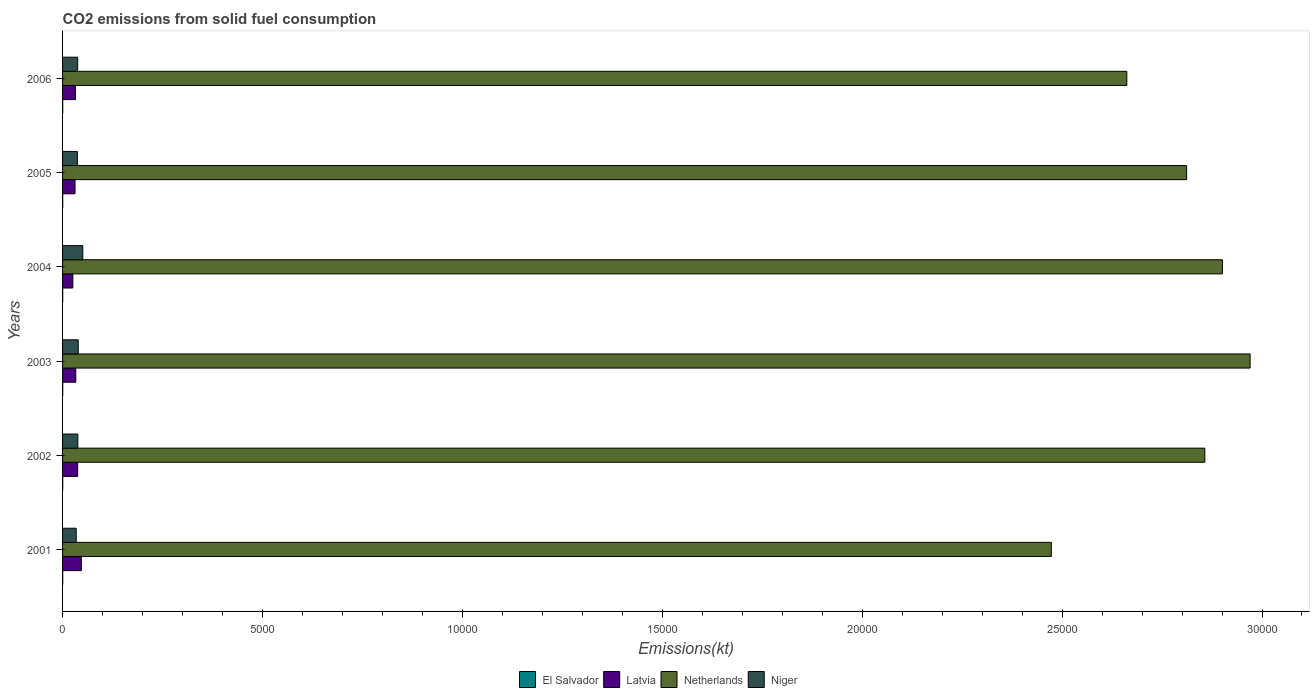What is the label of the 2nd group of bars from the top?
Offer a very short reply. 2005. In how many cases, is the number of bars for a given year not equal to the number of legend labels?
Your answer should be very brief. 0. What is the amount of CO2 emitted in Niger in 2004?
Your response must be concise. 506.05. Across all years, what is the maximum amount of CO2 emitted in Netherlands?
Provide a short and direct response. 2.97e+04. Across all years, what is the minimum amount of CO2 emitted in El Salvador?
Ensure brevity in your answer.  3.67. In which year was the amount of CO2 emitted in Niger maximum?
Offer a terse response. 2004. What is the total amount of CO2 emitted in Netherlands in the graph?
Keep it short and to the point. 1.67e+05. What is the difference between the amount of CO2 emitted in Netherlands in 2001 and that in 2005?
Your answer should be very brief. -3384.64. What is the difference between the amount of CO2 emitted in Latvia in 2006 and the amount of CO2 emitted in El Salvador in 2003?
Ensure brevity in your answer.  319.03. What is the average amount of CO2 emitted in El Salvador per year?
Ensure brevity in your answer.  3.67. In the year 2003, what is the difference between the amount of CO2 emitted in El Salvador and amount of CO2 emitted in Netherlands?
Make the answer very short. -2.97e+04. Is the amount of CO2 emitted in Netherlands in 2002 less than that in 2006?
Offer a terse response. No. What is the difference between the highest and the second highest amount of CO2 emitted in Niger?
Provide a short and direct response. 113.68. What is the difference between the highest and the lowest amount of CO2 emitted in Niger?
Make the answer very short. 165.01. In how many years, is the amount of CO2 emitted in Netherlands greater than the average amount of CO2 emitted in Netherlands taken over all years?
Ensure brevity in your answer.  4. Is the sum of the amount of CO2 emitted in El Salvador in 2001 and 2005 greater than the maximum amount of CO2 emitted in Niger across all years?
Your response must be concise. No. What does the 2nd bar from the top in 2001 represents?
Keep it short and to the point. Netherlands. Is it the case that in every year, the sum of the amount of CO2 emitted in Netherlands and amount of CO2 emitted in El Salvador is greater than the amount of CO2 emitted in Latvia?
Your answer should be compact. Yes. Are the values on the major ticks of X-axis written in scientific E-notation?
Make the answer very short. No. Does the graph contain grids?
Offer a very short reply. No. How are the legend labels stacked?
Offer a terse response. Horizontal. What is the title of the graph?
Make the answer very short. CO2 emissions from solid fuel consumption. What is the label or title of the X-axis?
Your answer should be very brief. Emissions(kt). What is the Emissions(kt) of El Salvador in 2001?
Offer a terse response. 3.67. What is the Emissions(kt) of Latvia in 2001?
Ensure brevity in your answer.  469.38. What is the Emissions(kt) in Netherlands in 2001?
Provide a short and direct response. 2.47e+04. What is the Emissions(kt) in Niger in 2001?
Provide a succinct answer. 341.03. What is the Emissions(kt) in El Salvador in 2002?
Offer a very short reply. 3.67. What is the Emissions(kt) of Latvia in 2002?
Give a very brief answer. 377.7. What is the Emissions(kt) in Netherlands in 2002?
Your answer should be compact. 2.86e+04. What is the Emissions(kt) of Niger in 2002?
Provide a succinct answer. 381.37. What is the Emissions(kt) in El Salvador in 2003?
Offer a very short reply. 3.67. What is the Emissions(kt) of Latvia in 2003?
Offer a very short reply. 330.03. What is the Emissions(kt) of Netherlands in 2003?
Keep it short and to the point. 2.97e+04. What is the Emissions(kt) of Niger in 2003?
Make the answer very short. 392.37. What is the Emissions(kt) in El Salvador in 2004?
Keep it short and to the point. 3.67. What is the Emissions(kt) of Latvia in 2004?
Your response must be concise. 256.69. What is the Emissions(kt) in Netherlands in 2004?
Your answer should be very brief. 2.90e+04. What is the Emissions(kt) of Niger in 2004?
Your response must be concise. 506.05. What is the Emissions(kt) in El Salvador in 2005?
Provide a short and direct response. 3.67. What is the Emissions(kt) of Latvia in 2005?
Ensure brevity in your answer.  311.69. What is the Emissions(kt) in Netherlands in 2005?
Your response must be concise. 2.81e+04. What is the Emissions(kt) of Niger in 2005?
Your answer should be compact. 370.37. What is the Emissions(kt) in El Salvador in 2006?
Your answer should be compact. 3.67. What is the Emissions(kt) of Latvia in 2006?
Keep it short and to the point. 322.7. What is the Emissions(kt) in Netherlands in 2006?
Give a very brief answer. 2.66e+04. What is the Emissions(kt) of Niger in 2006?
Ensure brevity in your answer.  377.7. Across all years, what is the maximum Emissions(kt) in El Salvador?
Make the answer very short. 3.67. Across all years, what is the maximum Emissions(kt) of Latvia?
Your response must be concise. 469.38. Across all years, what is the maximum Emissions(kt) in Netherlands?
Keep it short and to the point. 2.97e+04. Across all years, what is the maximum Emissions(kt) in Niger?
Your answer should be compact. 506.05. Across all years, what is the minimum Emissions(kt) of El Salvador?
Offer a very short reply. 3.67. Across all years, what is the minimum Emissions(kt) in Latvia?
Make the answer very short. 256.69. Across all years, what is the minimum Emissions(kt) in Netherlands?
Offer a terse response. 2.47e+04. Across all years, what is the minimum Emissions(kt) in Niger?
Offer a terse response. 341.03. What is the total Emissions(kt) in El Salvador in the graph?
Provide a short and direct response. 22. What is the total Emissions(kt) in Latvia in the graph?
Your response must be concise. 2068.19. What is the total Emissions(kt) in Netherlands in the graph?
Make the answer very short. 1.67e+05. What is the total Emissions(kt) of Niger in the graph?
Keep it short and to the point. 2368.88. What is the difference between the Emissions(kt) of Latvia in 2001 and that in 2002?
Give a very brief answer. 91.67. What is the difference between the Emissions(kt) in Netherlands in 2001 and that in 2002?
Keep it short and to the point. -3839.35. What is the difference between the Emissions(kt) in Niger in 2001 and that in 2002?
Provide a short and direct response. -40.34. What is the difference between the Emissions(kt) in Latvia in 2001 and that in 2003?
Provide a short and direct response. 139.35. What is the difference between the Emissions(kt) of Netherlands in 2001 and that in 2003?
Ensure brevity in your answer.  -4972.45. What is the difference between the Emissions(kt) in Niger in 2001 and that in 2003?
Offer a terse response. -51.34. What is the difference between the Emissions(kt) in El Salvador in 2001 and that in 2004?
Provide a succinct answer. 0. What is the difference between the Emissions(kt) of Latvia in 2001 and that in 2004?
Give a very brief answer. 212.69. What is the difference between the Emissions(kt) in Netherlands in 2001 and that in 2004?
Provide a short and direct response. -4279.39. What is the difference between the Emissions(kt) of Niger in 2001 and that in 2004?
Offer a very short reply. -165.01. What is the difference between the Emissions(kt) in El Salvador in 2001 and that in 2005?
Your response must be concise. 0. What is the difference between the Emissions(kt) of Latvia in 2001 and that in 2005?
Offer a very short reply. 157.68. What is the difference between the Emissions(kt) in Netherlands in 2001 and that in 2005?
Make the answer very short. -3384.64. What is the difference between the Emissions(kt) of Niger in 2001 and that in 2005?
Provide a succinct answer. -29.34. What is the difference between the Emissions(kt) in El Salvador in 2001 and that in 2006?
Provide a short and direct response. 0. What is the difference between the Emissions(kt) in Latvia in 2001 and that in 2006?
Offer a very short reply. 146.68. What is the difference between the Emissions(kt) in Netherlands in 2001 and that in 2006?
Offer a very short reply. -1888.51. What is the difference between the Emissions(kt) in Niger in 2001 and that in 2006?
Your response must be concise. -36.67. What is the difference between the Emissions(kt) of Latvia in 2002 and that in 2003?
Your response must be concise. 47.67. What is the difference between the Emissions(kt) in Netherlands in 2002 and that in 2003?
Ensure brevity in your answer.  -1133.1. What is the difference between the Emissions(kt) in Niger in 2002 and that in 2003?
Your response must be concise. -11. What is the difference between the Emissions(kt) of El Salvador in 2002 and that in 2004?
Make the answer very short. 0. What is the difference between the Emissions(kt) in Latvia in 2002 and that in 2004?
Offer a terse response. 121.01. What is the difference between the Emissions(kt) of Netherlands in 2002 and that in 2004?
Provide a short and direct response. -440.04. What is the difference between the Emissions(kt) in Niger in 2002 and that in 2004?
Your response must be concise. -124.68. What is the difference between the Emissions(kt) of El Salvador in 2002 and that in 2005?
Ensure brevity in your answer.  0. What is the difference between the Emissions(kt) of Latvia in 2002 and that in 2005?
Keep it short and to the point. 66.01. What is the difference between the Emissions(kt) in Netherlands in 2002 and that in 2005?
Offer a terse response. 454.71. What is the difference between the Emissions(kt) in Niger in 2002 and that in 2005?
Give a very brief answer. 11. What is the difference between the Emissions(kt) of El Salvador in 2002 and that in 2006?
Provide a succinct answer. 0. What is the difference between the Emissions(kt) in Latvia in 2002 and that in 2006?
Provide a short and direct response. 55.01. What is the difference between the Emissions(kt) in Netherlands in 2002 and that in 2006?
Provide a short and direct response. 1950.84. What is the difference between the Emissions(kt) in Niger in 2002 and that in 2006?
Give a very brief answer. 3.67. What is the difference between the Emissions(kt) of El Salvador in 2003 and that in 2004?
Ensure brevity in your answer.  0. What is the difference between the Emissions(kt) of Latvia in 2003 and that in 2004?
Ensure brevity in your answer.  73.34. What is the difference between the Emissions(kt) of Netherlands in 2003 and that in 2004?
Make the answer very short. 693.06. What is the difference between the Emissions(kt) of Niger in 2003 and that in 2004?
Offer a very short reply. -113.68. What is the difference between the Emissions(kt) in Latvia in 2003 and that in 2005?
Offer a terse response. 18.34. What is the difference between the Emissions(kt) of Netherlands in 2003 and that in 2005?
Ensure brevity in your answer.  1587.81. What is the difference between the Emissions(kt) in Niger in 2003 and that in 2005?
Offer a terse response. 22. What is the difference between the Emissions(kt) of El Salvador in 2003 and that in 2006?
Your answer should be very brief. 0. What is the difference between the Emissions(kt) in Latvia in 2003 and that in 2006?
Offer a very short reply. 7.33. What is the difference between the Emissions(kt) in Netherlands in 2003 and that in 2006?
Provide a succinct answer. 3083.95. What is the difference between the Emissions(kt) of Niger in 2003 and that in 2006?
Offer a terse response. 14.67. What is the difference between the Emissions(kt) in Latvia in 2004 and that in 2005?
Make the answer very short. -55.01. What is the difference between the Emissions(kt) of Netherlands in 2004 and that in 2005?
Offer a terse response. 894.75. What is the difference between the Emissions(kt) of Niger in 2004 and that in 2005?
Your response must be concise. 135.68. What is the difference between the Emissions(kt) of El Salvador in 2004 and that in 2006?
Your answer should be compact. 0. What is the difference between the Emissions(kt) in Latvia in 2004 and that in 2006?
Your response must be concise. -66.01. What is the difference between the Emissions(kt) of Netherlands in 2004 and that in 2006?
Your answer should be very brief. 2390.88. What is the difference between the Emissions(kt) of Niger in 2004 and that in 2006?
Offer a very short reply. 128.34. What is the difference between the Emissions(kt) of El Salvador in 2005 and that in 2006?
Ensure brevity in your answer.  0. What is the difference between the Emissions(kt) of Latvia in 2005 and that in 2006?
Make the answer very short. -11. What is the difference between the Emissions(kt) in Netherlands in 2005 and that in 2006?
Give a very brief answer. 1496.14. What is the difference between the Emissions(kt) of Niger in 2005 and that in 2006?
Offer a terse response. -7.33. What is the difference between the Emissions(kt) of El Salvador in 2001 and the Emissions(kt) of Latvia in 2002?
Make the answer very short. -374.03. What is the difference between the Emissions(kt) of El Salvador in 2001 and the Emissions(kt) of Netherlands in 2002?
Offer a terse response. -2.86e+04. What is the difference between the Emissions(kt) of El Salvador in 2001 and the Emissions(kt) of Niger in 2002?
Give a very brief answer. -377.7. What is the difference between the Emissions(kt) of Latvia in 2001 and the Emissions(kt) of Netherlands in 2002?
Offer a very short reply. -2.81e+04. What is the difference between the Emissions(kt) in Latvia in 2001 and the Emissions(kt) in Niger in 2002?
Your response must be concise. 88.01. What is the difference between the Emissions(kt) in Netherlands in 2001 and the Emissions(kt) in Niger in 2002?
Make the answer very short. 2.43e+04. What is the difference between the Emissions(kt) of El Salvador in 2001 and the Emissions(kt) of Latvia in 2003?
Give a very brief answer. -326.36. What is the difference between the Emissions(kt) of El Salvador in 2001 and the Emissions(kt) of Netherlands in 2003?
Make the answer very short. -2.97e+04. What is the difference between the Emissions(kt) in El Salvador in 2001 and the Emissions(kt) in Niger in 2003?
Provide a short and direct response. -388.7. What is the difference between the Emissions(kt) in Latvia in 2001 and the Emissions(kt) in Netherlands in 2003?
Provide a succinct answer. -2.92e+04. What is the difference between the Emissions(kt) of Latvia in 2001 and the Emissions(kt) of Niger in 2003?
Provide a short and direct response. 77.01. What is the difference between the Emissions(kt) of Netherlands in 2001 and the Emissions(kt) of Niger in 2003?
Your answer should be very brief. 2.43e+04. What is the difference between the Emissions(kt) in El Salvador in 2001 and the Emissions(kt) in Latvia in 2004?
Provide a succinct answer. -253.02. What is the difference between the Emissions(kt) in El Salvador in 2001 and the Emissions(kt) in Netherlands in 2004?
Provide a short and direct response. -2.90e+04. What is the difference between the Emissions(kt) in El Salvador in 2001 and the Emissions(kt) in Niger in 2004?
Offer a terse response. -502.38. What is the difference between the Emissions(kt) in Latvia in 2001 and the Emissions(kt) in Netherlands in 2004?
Keep it short and to the point. -2.85e+04. What is the difference between the Emissions(kt) of Latvia in 2001 and the Emissions(kt) of Niger in 2004?
Your answer should be very brief. -36.67. What is the difference between the Emissions(kt) of Netherlands in 2001 and the Emissions(kt) of Niger in 2004?
Your response must be concise. 2.42e+04. What is the difference between the Emissions(kt) in El Salvador in 2001 and the Emissions(kt) in Latvia in 2005?
Offer a very short reply. -308.03. What is the difference between the Emissions(kt) in El Salvador in 2001 and the Emissions(kt) in Netherlands in 2005?
Offer a terse response. -2.81e+04. What is the difference between the Emissions(kt) in El Salvador in 2001 and the Emissions(kt) in Niger in 2005?
Provide a short and direct response. -366.7. What is the difference between the Emissions(kt) of Latvia in 2001 and the Emissions(kt) of Netherlands in 2005?
Offer a terse response. -2.76e+04. What is the difference between the Emissions(kt) of Latvia in 2001 and the Emissions(kt) of Niger in 2005?
Offer a very short reply. 99.01. What is the difference between the Emissions(kt) in Netherlands in 2001 and the Emissions(kt) in Niger in 2005?
Provide a succinct answer. 2.44e+04. What is the difference between the Emissions(kt) of El Salvador in 2001 and the Emissions(kt) of Latvia in 2006?
Ensure brevity in your answer.  -319.03. What is the difference between the Emissions(kt) of El Salvador in 2001 and the Emissions(kt) of Netherlands in 2006?
Make the answer very short. -2.66e+04. What is the difference between the Emissions(kt) of El Salvador in 2001 and the Emissions(kt) of Niger in 2006?
Provide a short and direct response. -374.03. What is the difference between the Emissions(kt) of Latvia in 2001 and the Emissions(kt) of Netherlands in 2006?
Give a very brief answer. -2.61e+04. What is the difference between the Emissions(kt) in Latvia in 2001 and the Emissions(kt) in Niger in 2006?
Make the answer very short. 91.67. What is the difference between the Emissions(kt) of Netherlands in 2001 and the Emissions(kt) of Niger in 2006?
Your answer should be very brief. 2.44e+04. What is the difference between the Emissions(kt) in El Salvador in 2002 and the Emissions(kt) in Latvia in 2003?
Offer a terse response. -326.36. What is the difference between the Emissions(kt) of El Salvador in 2002 and the Emissions(kt) of Netherlands in 2003?
Offer a very short reply. -2.97e+04. What is the difference between the Emissions(kt) of El Salvador in 2002 and the Emissions(kt) of Niger in 2003?
Provide a succinct answer. -388.7. What is the difference between the Emissions(kt) of Latvia in 2002 and the Emissions(kt) of Netherlands in 2003?
Provide a short and direct response. -2.93e+04. What is the difference between the Emissions(kt) of Latvia in 2002 and the Emissions(kt) of Niger in 2003?
Provide a short and direct response. -14.67. What is the difference between the Emissions(kt) of Netherlands in 2002 and the Emissions(kt) of Niger in 2003?
Offer a terse response. 2.82e+04. What is the difference between the Emissions(kt) of El Salvador in 2002 and the Emissions(kt) of Latvia in 2004?
Make the answer very short. -253.02. What is the difference between the Emissions(kt) of El Salvador in 2002 and the Emissions(kt) of Netherlands in 2004?
Your response must be concise. -2.90e+04. What is the difference between the Emissions(kt) of El Salvador in 2002 and the Emissions(kt) of Niger in 2004?
Keep it short and to the point. -502.38. What is the difference between the Emissions(kt) of Latvia in 2002 and the Emissions(kt) of Netherlands in 2004?
Keep it short and to the point. -2.86e+04. What is the difference between the Emissions(kt) in Latvia in 2002 and the Emissions(kt) in Niger in 2004?
Your answer should be very brief. -128.34. What is the difference between the Emissions(kt) in Netherlands in 2002 and the Emissions(kt) in Niger in 2004?
Provide a short and direct response. 2.81e+04. What is the difference between the Emissions(kt) in El Salvador in 2002 and the Emissions(kt) in Latvia in 2005?
Provide a short and direct response. -308.03. What is the difference between the Emissions(kt) of El Salvador in 2002 and the Emissions(kt) of Netherlands in 2005?
Provide a succinct answer. -2.81e+04. What is the difference between the Emissions(kt) of El Salvador in 2002 and the Emissions(kt) of Niger in 2005?
Provide a succinct answer. -366.7. What is the difference between the Emissions(kt) of Latvia in 2002 and the Emissions(kt) of Netherlands in 2005?
Your answer should be very brief. -2.77e+04. What is the difference between the Emissions(kt) of Latvia in 2002 and the Emissions(kt) of Niger in 2005?
Provide a succinct answer. 7.33. What is the difference between the Emissions(kt) of Netherlands in 2002 and the Emissions(kt) of Niger in 2005?
Give a very brief answer. 2.82e+04. What is the difference between the Emissions(kt) of El Salvador in 2002 and the Emissions(kt) of Latvia in 2006?
Provide a succinct answer. -319.03. What is the difference between the Emissions(kt) of El Salvador in 2002 and the Emissions(kt) of Netherlands in 2006?
Provide a short and direct response. -2.66e+04. What is the difference between the Emissions(kt) of El Salvador in 2002 and the Emissions(kt) of Niger in 2006?
Offer a terse response. -374.03. What is the difference between the Emissions(kt) in Latvia in 2002 and the Emissions(kt) in Netherlands in 2006?
Give a very brief answer. -2.62e+04. What is the difference between the Emissions(kt) of Latvia in 2002 and the Emissions(kt) of Niger in 2006?
Give a very brief answer. 0. What is the difference between the Emissions(kt) of Netherlands in 2002 and the Emissions(kt) of Niger in 2006?
Make the answer very short. 2.82e+04. What is the difference between the Emissions(kt) in El Salvador in 2003 and the Emissions(kt) in Latvia in 2004?
Offer a terse response. -253.02. What is the difference between the Emissions(kt) in El Salvador in 2003 and the Emissions(kt) in Netherlands in 2004?
Provide a short and direct response. -2.90e+04. What is the difference between the Emissions(kt) of El Salvador in 2003 and the Emissions(kt) of Niger in 2004?
Provide a succinct answer. -502.38. What is the difference between the Emissions(kt) of Latvia in 2003 and the Emissions(kt) of Netherlands in 2004?
Provide a short and direct response. -2.87e+04. What is the difference between the Emissions(kt) in Latvia in 2003 and the Emissions(kt) in Niger in 2004?
Provide a succinct answer. -176.02. What is the difference between the Emissions(kt) in Netherlands in 2003 and the Emissions(kt) in Niger in 2004?
Your response must be concise. 2.92e+04. What is the difference between the Emissions(kt) in El Salvador in 2003 and the Emissions(kt) in Latvia in 2005?
Your answer should be compact. -308.03. What is the difference between the Emissions(kt) in El Salvador in 2003 and the Emissions(kt) in Netherlands in 2005?
Your response must be concise. -2.81e+04. What is the difference between the Emissions(kt) in El Salvador in 2003 and the Emissions(kt) in Niger in 2005?
Make the answer very short. -366.7. What is the difference between the Emissions(kt) in Latvia in 2003 and the Emissions(kt) in Netherlands in 2005?
Offer a very short reply. -2.78e+04. What is the difference between the Emissions(kt) of Latvia in 2003 and the Emissions(kt) of Niger in 2005?
Offer a terse response. -40.34. What is the difference between the Emissions(kt) of Netherlands in 2003 and the Emissions(kt) of Niger in 2005?
Your response must be concise. 2.93e+04. What is the difference between the Emissions(kt) of El Salvador in 2003 and the Emissions(kt) of Latvia in 2006?
Your response must be concise. -319.03. What is the difference between the Emissions(kt) in El Salvador in 2003 and the Emissions(kt) in Netherlands in 2006?
Provide a succinct answer. -2.66e+04. What is the difference between the Emissions(kt) of El Salvador in 2003 and the Emissions(kt) of Niger in 2006?
Offer a very short reply. -374.03. What is the difference between the Emissions(kt) in Latvia in 2003 and the Emissions(kt) in Netherlands in 2006?
Keep it short and to the point. -2.63e+04. What is the difference between the Emissions(kt) in Latvia in 2003 and the Emissions(kt) in Niger in 2006?
Your answer should be compact. -47.67. What is the difference between the Emissions(kt) in Netherlands in 2003 and the Emissions(kt) in Niger in 2006?
Your answer should be very brief. 2.93e+04. What is the difference between the Emissions(kt) in El Salvador in 2004 and the Emissions(kt) in Latvia in 2005?
Offer a very short reply. -308.03. What is the difference between the Emissions(kt) in El Salvador in 2004 and the Emissions(kt) in Netherlands in 2005?
Your answer should be very brief. -2.81e+04. What is the difference between the Emissions(kt) in El Salvador in 2004 and the Emissions(kt) in Niger in 2005?
Ensure brevity in your answer.  -366.7. What is the difference between the Emissions(kt) of Latvia in 2004 and the Emissions(kt) of Netherlands in 2005?
Your answer should be compact. -2.79e+04. What is the difference between the Emissions(kt) of Latvia in 2004 and the Emissions(kt) of Niger in 2005?
Give a very brief answer. -113.68. What is the difference between the Emissions(kt) of Netherlands in 2004 and the Emissions(kt) of Niger in 2005?
Ensure brevity in your answer.  2.86e+04. What is the difference between the Emissions(kt) in El Salvador in 2004 and the Emissions(kt) in Latvia in 2006?
Offer a very short reply. -319.03. What is the difference between the Emissions(kt) in El Salvador in 2004 and the Emissions(kt) in Netherlands in 2006?
Offer a terse response. -2.66e+04. What is the difference between the Emissions(kt) in El Salvador in 2004 and the Emissions(kt) in Niger in 2006?
Make the answer very short. -374.03. What is the difference between the Emissions(kt) in Latvia in 2004 and the Emissions(kt) in Netherlands in 2006?
Your response must be concise. -2.64e+04. What is the difference between the Emissions(kt) of Latvia in 2004 and the Emissions(kt) of Niger in 2006?
Keep it short and to the point. -121.01. What is the difference between the Emissions(kt) in Netherlands in 2004 and the Emissions(kt) in Niger in 2006?
Provide a succinct answer. 2.86e+04. What is the difference between the Emissions(kt) of El Salvador in 2005 and the Emissions(kt) of Latvia in 2006?
Ensure brevity in your answer.  -319.03. What is the difference between the Emissions(kt) in El Salvador in 2005 and the Emissions(kt) in Netherlands in 2006?
Offer a terse response. -2.66e+04. What is the difference between the Emissions(kt) in El Salvador in 2005 and the Emissions(kt) in Niger in 2006?
Offer a very short reply. -374.03. What is the difference between the Emissions(kt) in Latvia in 2005 and the Emissions(kt) in Netherlands in 2006?
Your answer should be compact. -2.63e+04. What is the difference between the Emissions(kt) in Latvia in 2005 and the Emissions(kt) in Niger in 2006?
Ensure brevity in your answer.  -66.01. What is the difference between the Emissions(kt) in Netherlands in 2005 and the Emissions(kt) in Niger in 2006?
Provide a succinct answer. 2.77e+04. What is the average Emissions(kt) in El Salvador per year?
Your response must be concise. 3.67. What is the average Emissions(kt) of Latvia per year?
Provide a short and direct response. 344.7. What is the average Emissions(kt) in Netherlands per year?
Make the answer very short. 2.78e+04. What is the average Emissions(kt) of Niger per year?
Offer a terse response. 394.81. In the year 2001, what is the difference between the Emissions(kt) of El Salvador and Emissions(kt) of Latvia?
Provide a succinct answer. -465.71. In the year 2001, what is the difference between the Emissions(kt) in El Salvador and Emissions(kt) in Netherlands?
Your answer should be compact. -2.47e+04. In the year 2001, what is the difference between the Emissions(kt) of El Salvador and Emissions(kt) of Niger?
Ensure brevity in your answer.  -337.36. In the year 2001, what is the difference between the Emissions(kt) of Latvia and Emissions(kt) of Netherlands?
Make the answer very short. -2.43e+04. In the year 2001, what is the difference between the Emissions(kt) in Latvia and Emissions(kt) in Niger?
Keep it short and to the point. 128.34. In the year 2001, what is the difference between the Emissions(kt) of Netherlands and Emissions(kt) of Niger?
Your response must be concise. 2.44e+04. In the year 2002, what is the difference between the Emissions(kt) of El Salvador and Emissions(kt) of Latvia?
Give a very brief answer. -374.03. In the year 2002, what is the difference between the Emissions(kt) of El Salvador and Emissions(kt) of Netherlands?
Keep it short and to the point. -2.86e+04. In the year 2002, what is the difference between the Emissions(kt) in El Salvador and Emissions(kt) in Niger?
Your answer should be very brief. -377.7. In the year 2002, what is the difference between the Emissions(kt) of Latvia and Emissions(kt) of Netherlands?
Provide a succinct answer. -2.82e+04. In the year 2002, what is the difference between the Emissions(kt) in Latvia and Emissions(kt) in Niger?
Offer a terse response. -3.67. In the year 2002, what is the difference between the Emissions(kt) of Netherlands and Emissions(kt) of Niger?
Offer a very short reply. 2.82e+04. In the year 2003, what is the difference between the Emissions(kt) in El Salvador and Emissions(kt) in Latvia?
Your answer should be very brief. -326.36. In the year 2003, what is the difference between the Emissions(kt) in El Salvador and Emissions(kt) in Netherlands?
Keep it short and to the point. -2.97e+04. In the year 2003, what is the difference between the Emissions(kt) of El Salvador and Emissions(kt) of Niger?
Make the answer very short. -388.7. In the year 2003, what is the difference between the Emissions(kt) in Latvia and Emissions(kt) in Netherlands?
Provide a short and direct response. -2.94e+04. In the year 2003, what is the difference between the Emissions(kt) of Latvia and Emissions(kt) of Niger?
Your response must be concise. -62.34. In the year 2003, what is the difference between the Emissions(kt) of Netherlands and Emissions(kt) of Niger?
Your response must be concise. 2.93e+04. In the year 2004, what is the difference between the Emissions(kt) of El Salvador and Emissions(kt) of Latvia?
Ensure brevity in your answer.  -253.02. In the year 2004, what is the difference between the Emissions(kt) of El Salvador and Emissions(kt) of Netherlands?
Your answer should be compact. -2.90e+04. In the year 2004, what is the difference between the Emissions(kt) in El Salvador and Emissions(kt) in Niger?
Your response must be concise. -502.38. In the year 2004, what is the difference between the Emissions(kt) of Latvia and Emissions(kt) of Netherlands?
Provide a succinct answer. -2.88e+04. In the year 2004, what is the difference between the Emissions(kt) in Latvia and Emissions(kt) in Niger?
Your response must be concise. -249.36. In the year 2004, what is the difference between the Emissions(kt) of Netherlands and Emissions(kt) of Niger?
Your answer should be very brief. 2.85e+04. In the year 2005, what is the difference between the Emissions(kt) of El Salvador and Emissions(kt) of Latvia?
Keep it short and to the point. -308.03. In the year 2005, what is the difference between the Emissions(kt) in El Salvador and Emissions(kt) in Netherlands?
Offer a very short reply. -2.81e+04. In the year 2005, what is the difference between the Emissions(kt) in El Salvador and Emissions(kt) in Niger?
Make the answer very short. -366.7. In the year 2005, what is the difference between the Emissions(kt) of Latvia and Emissions(kt) of Netherlands?
Provide a short and direct response. -2.78e+04. In the year 2005, what is the difference between the Emissions(kt) in Latvia and Emissions(kt) in Niger?
Provide a succinct answer. -58.67. In the year 2005, what is the difference between the Emissions(kt) in Netherlands and Emissions(kt) in Niger?
Make the answer very short. 2.77e+04. In the year 2006, what is the difference between the Emissions(kt) of El Salvador and Emissions(kt) of Latvia?
Make the answer very short. -319.03. In the year 2006, what is the difference between the Emissions(kt) in El Salvador and Emissions(kt) in Netherlands?
Your response must be concise. -2.66e+04. In the year 2006, what is the difference between the Emissions(kt) in El Salvador and Emissions(kt) in Niger?
Give a very brief answer. -374.03. In the year 2006, what is the difference between the Emissions(kt) in Latvia and Emissions(kt) in Netherlands?
Provide a short and direct response. -2.63e+04. In the year 2006, what is the difference between the Emissions(kt) of Latvia and Emissions(kt) of Niger?
Offer a terse response. -55.01. In the year 2006, what is the difference between the Emissions(kt) in Netherlands and Emissions(kt) in Niger?
Offer a very short reply. 2.62e+04. What is the ratio of the Emissions(kt) in El Salvador in 2001 to that in 2002?
Provide a short and direct response. 1. What is the ratio of the Emissions(kt) in Latvia in 2001 to that in 2002?
Make the answer very short. 1.24. What is the ratio of the Emissions(kt) in Netherlands in 2001 to that in 2002?
Provide a succinct answer. 0.87. What is the ratio of the Emissions(kt) of Niger in 2001 to that in 2002?
Provide a short and direct response. 0.89. What is the ratio of the Emissions(kt) of El Salvador in 2001 to that in 2003?
Ensure brevity in your answer.  1. What is the ratio of the Emissions(kt) in Latvia in 2001 to that in 2003?
Your answer should be very brief. 1.42. What is the ratio of the Emissions(kt) of Netherlands in 2001 to that in 2003?
Provide a short and direct response. 0.83. What is the ratio of the Emissions(kt) in Niger in 2001 to that in 2003?
Offer a very short reply. 0.87. What is the ratio of the Emissions(kt) in Latvia in 2001 to that in 2004?
Ensure brevity in your answer.  1.83. What is the ratio of the Emissions(kt) of Netherlands in 2001 to that in 2004?
Provide a succinct answer. 0.85. What is the ratio of the Emissions(kt) of Niger in 2001 to that in 2004?
Provide a short and direct response. 0.67. What is the ratio of the Emissions(kt) in Latvia in 2001 to that in 2005?
Give a very brief answer. 1.51. What is the ratio of the Emissions(kt) of Netherlands in 2001 to that in 2005?
Your answer should be compact. 0.88. What is the ratio of the Emissions(kt) of Niger in 2001 to that in 2005?
Offer a very short reply. 0.92. What is the ratio of the Emissions(kt) of El Salvador in 2001 to that in 2006?
Offer a very short reply. 1. What is the ratio of the Emissions(kt) of Latvia in 2001 to that in 2006?
Provide a succinct answer. 1.45. What is the ratio of the Emissions(kt) in Netherlands in 2001 to that in 2006?
Provide a succinct answer. 0.93. What is the ratio of the Emissions(kt) in Niger in 2001 to that in 2006?
Your response must be concise. 0.9. What is the ratio of the Emissions(kt) in Latvia in 2002 to that in 2003?
Your response must be concise. 1.14. What is the ratio of the Emissions(kt) in Netherlands in 2002 to that in 2003?
Your answer should be compact. 0.96. What is the ratio of the Emissions(kt) of Niger in 2002 to that in 2003?
Offer a terse response. 0.97. What is the ratio of the Emissions(kt) in El Salvador in 2002 to that in 2004?
Keep it short and to the point. 1. What is the ratio of the Emissions(kt) of Latvia in 2002 to that in 2004?
Keep it short and to the point. 1.47. What is the ratio of the Emissions(kt) in Niger in 2002 to that in 2004?
Offer a terse response. 0.75. What is the ratio of the Emissions(kt) in El Salvador in 2002 to that in 2005?
Your response must be concise. 1. What is the ratio of the Emissions(kt) of Latvia in 2002 to that in 2005?
Give a very brief answer. 1.21. What is the ratio of the Emissions(kt) in Netherlands in 2002 to that in 2005?
Provide a succinct answer. 1.02. What is the ratio of the Emissions(kt) in Niger in 2002 to that in 2005?
Your answer should be very brief. 1.03. What is the ratio of the Emissions(kt) in Latvia in 2002 to that in 2006?
Make the answer very short. 1.17. What is the ratio of the Emissions(kt) of Netherlands in 2002 to that in 2006?
Your answer should be very brief. 1.07. What is the ratio of the Emissions(kt) in Niger in 2002 to that in 2006?
Give a very brief answer. 1.01. What is the ratio of the Emissions(kt) of Netherlands in 2003 to that in 2004?
Ensure brevity in your answer.  1.02. What is the ratio of the Emissions(kt) in Niger in 2003 to that in 2004?
Provide a short and direct response. 0.78. What is the ratio of the Emissions(kt) in Latvia in 2003 to that in 2005?
Your answer should be very brief. 1.06. What is the ratio of the Emissions(kt) in Netherlands in 2003 to that in 2005?
Give a very brief answer. 1.06. What is the ratio of the Emissions(kt) in Niger in 2003 to that in 2005?
Keep it short and to the point. 1.06. What is the ratio of the Emissions(kt) in Latvia in 2003 to that in 2006?
Make the answer very short. 1.02. What is the ratio of the Emissions(kt) of Netherlands in 2003 to that in 2006?
Provide a short and direct response. 1.12. What is the ratio of the Emissions(kt) in Niger in 2003 to that in 2006?
Your answer should be very brief. 1.04. What is the ratio of the Emissions(kt) in El Salvador in 2004 to that in 2005?
Provide a succinct answer. 1. What is the ratio of the Emissions(kt) of Latvia in 2004 to that in 2005?
Give a very brief answer. 0.82. What is the ratio of the Emissions(kt) in Netherlands in 2004 to that in 2005?
Offer a terse response. 1.03. What is the ratio of the Emissions(kt) in Niger in 2004 to that in 2005?
Offer a very short reply. 1.37. What is the ratio of the Emissions(kt) in Latvia in 2004 to that in 2006?
Your answer should be very brief. 0.8. What is the ratio of the Emissions(kt) in Netherlands in 2004 to that in 2006?
Offer a terse response. 1.09. What is the ratio of the Emissions(kt) of Niger in 2004 to that in 2006?
Your answer should be compact. 1.34. What is the ratio of the Emissions(kt) in Latvia in 2005 to that in 2006?
Your response must be concise. 0.97. What is the ratio of the Emissions(kt) in Netherlands in 2005 to that in 2006?
Give a very brief answer. 1.06. What is the ratio of the Emissions(kt) of Niger in 2005 to that in 2006?
Keep it short and to the point. 0.98. What is the difference between the highest and the second highest Emissions(kt) of Latvia?
Your response must be concise. 91.67. What is the difference between the highest and the second highest Emissions(kt) in Netherlands?
Keep it short and to the point. 693.06. What is the difference between the highest and the second highest Emissions(kt) of Niger?
Provide a short and direct response. 113.68. What is the difference between the highest and the lowest Emissions(kt) in El Salvador?
Offer a terse response. 0. What is the difference between the highest and the lowest Emissions(kt) of Latvia?
Ensure brevity in your answer.  212.69. What is the difference between the highest and the lowest Emissions(kt) in Netherlands?
Your answer should be very brief. 4972.45. What is the difference between the highest and the lowest Emissions(kt) in Niger?
Provide a succinct answer. 165.01. 